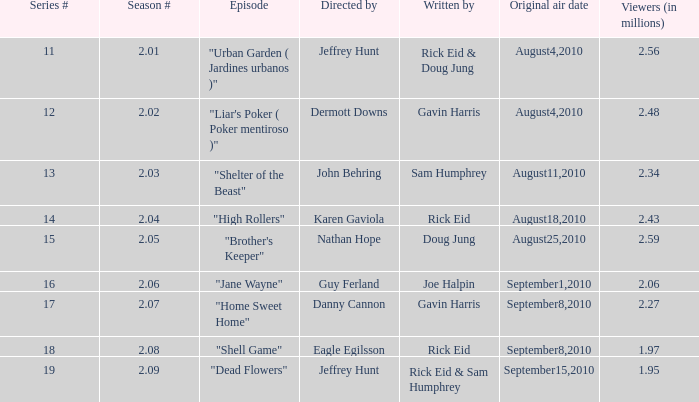What is the amount of viewers if the series number is 14? 2.43. 